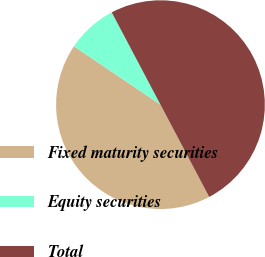<chart> <loc_0><loc_0><loc_500><loc_500><pie_chart><fcel>Fixed maturity securities<fcel>Equity securities<fcel>Total<nl><fcel>42.18%<fcel>7.82%<fcel>50.0%<nl></chart> 